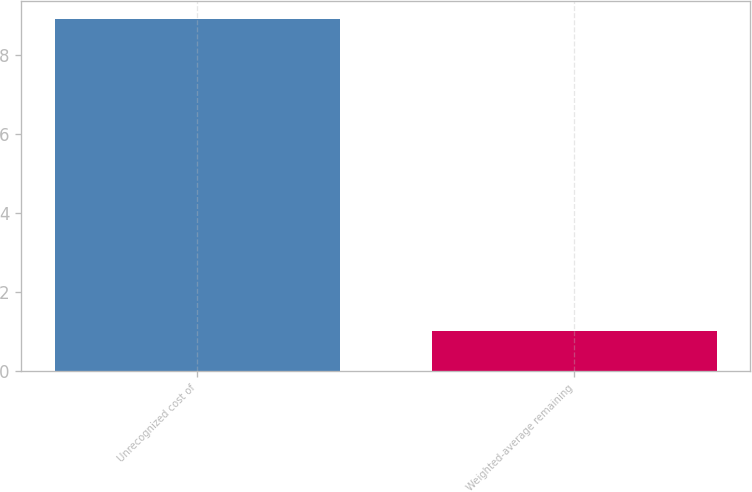Convert chart to OTSL. <chart><loc_0><loc_0><loc_500><loc_500><bar_chart><fcel>Unrecognized cost of<fcel>Weighted-average remaining<nl><fcel>8.9<fcel>1<nl></chart> 